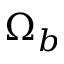<formula> <loc_0><loc_0><loc_500><loc_500>\Omega _ { b }</formula> 